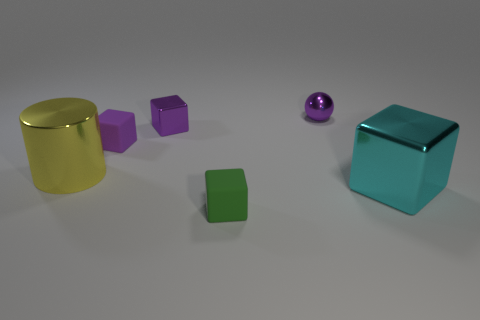Are there any other things that have the same size as the yellow thing?
Provide a short and direct response. Yes. What material is the other block that is the same color as the small metal cube?
Make the answer very short. Rubber. What number of other objects are the same material as the tiny green cube?
Provide a succinct answer. 1. Is the size of the cyan metallic object the same as the rubber object in front of the cylinder?
Provide a succinct answer. No. What is the color of the small metal ball?
Your response must be concise. Purple. The shiny object that is left of the small shiny thing that is on the left side of the purple object that is right of the green rubber cube is what shape?
Make the answer very short. Cylinder. What is the material of the tiny block in front of the big object that is on the right side of the yellow metal cylinder?
Make the answer very short. Rubber. The big thing that is made of the same material as the cylinder is what shape?
Your answer should be very brief. Cube. Is there any other thing that has the same shape as the large cyan thing?
Offer a terse response. Yes. What number of green rubber objects are right of the shiny cylinder?
Offer a very short reply. 1. 